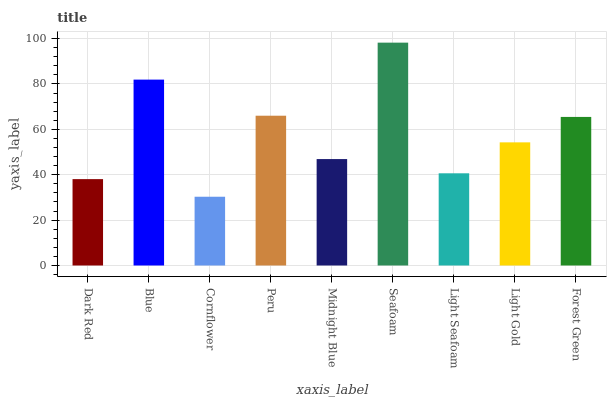Is Cornflower the minimum?
Answer yes or no. Yes. Is Seafoam the maximum?
Answer yes or no. Yes. Is Blue the minimum?
Answer yes or no. No. Is Blue the maximum?
Answer yes or no. No. Is Blue greater than Dark Red?
Answer yes or no. Yes. Is Dark Red less than Blue?
Answer yes or no. Yes. Is Dark Red greater than Blue?
Answer yes or no. No. Is Blue less than Dark Red?
Answer yes or no. No. Is Light Gold the high median?
Answer yes or no. Yes. Is Light Gold the low median?
Answer yes or no. Yes. Is Seafoam the high median?
Answer yes or no. No. Is Blue the low median?
Answer yes or no. No. 